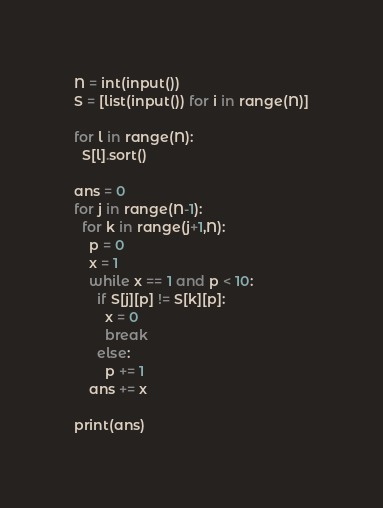<code> <loc_0><loc_0><loc_500><loc_500><_Python_>N = int(input())
S = [list(input()) for i in range(N)]

for l in range(N):
  S[l].sort()

ans = 0
for j in range(N-1):
  for k in range(j+1,N):
    p = 0
    x = 1
    while x == 1 and p < 10:
      if S[j][p] != S[k][p]:
        x = 0
        break
      else:
        p += 1
    ans += x

print(ans)
</code> 